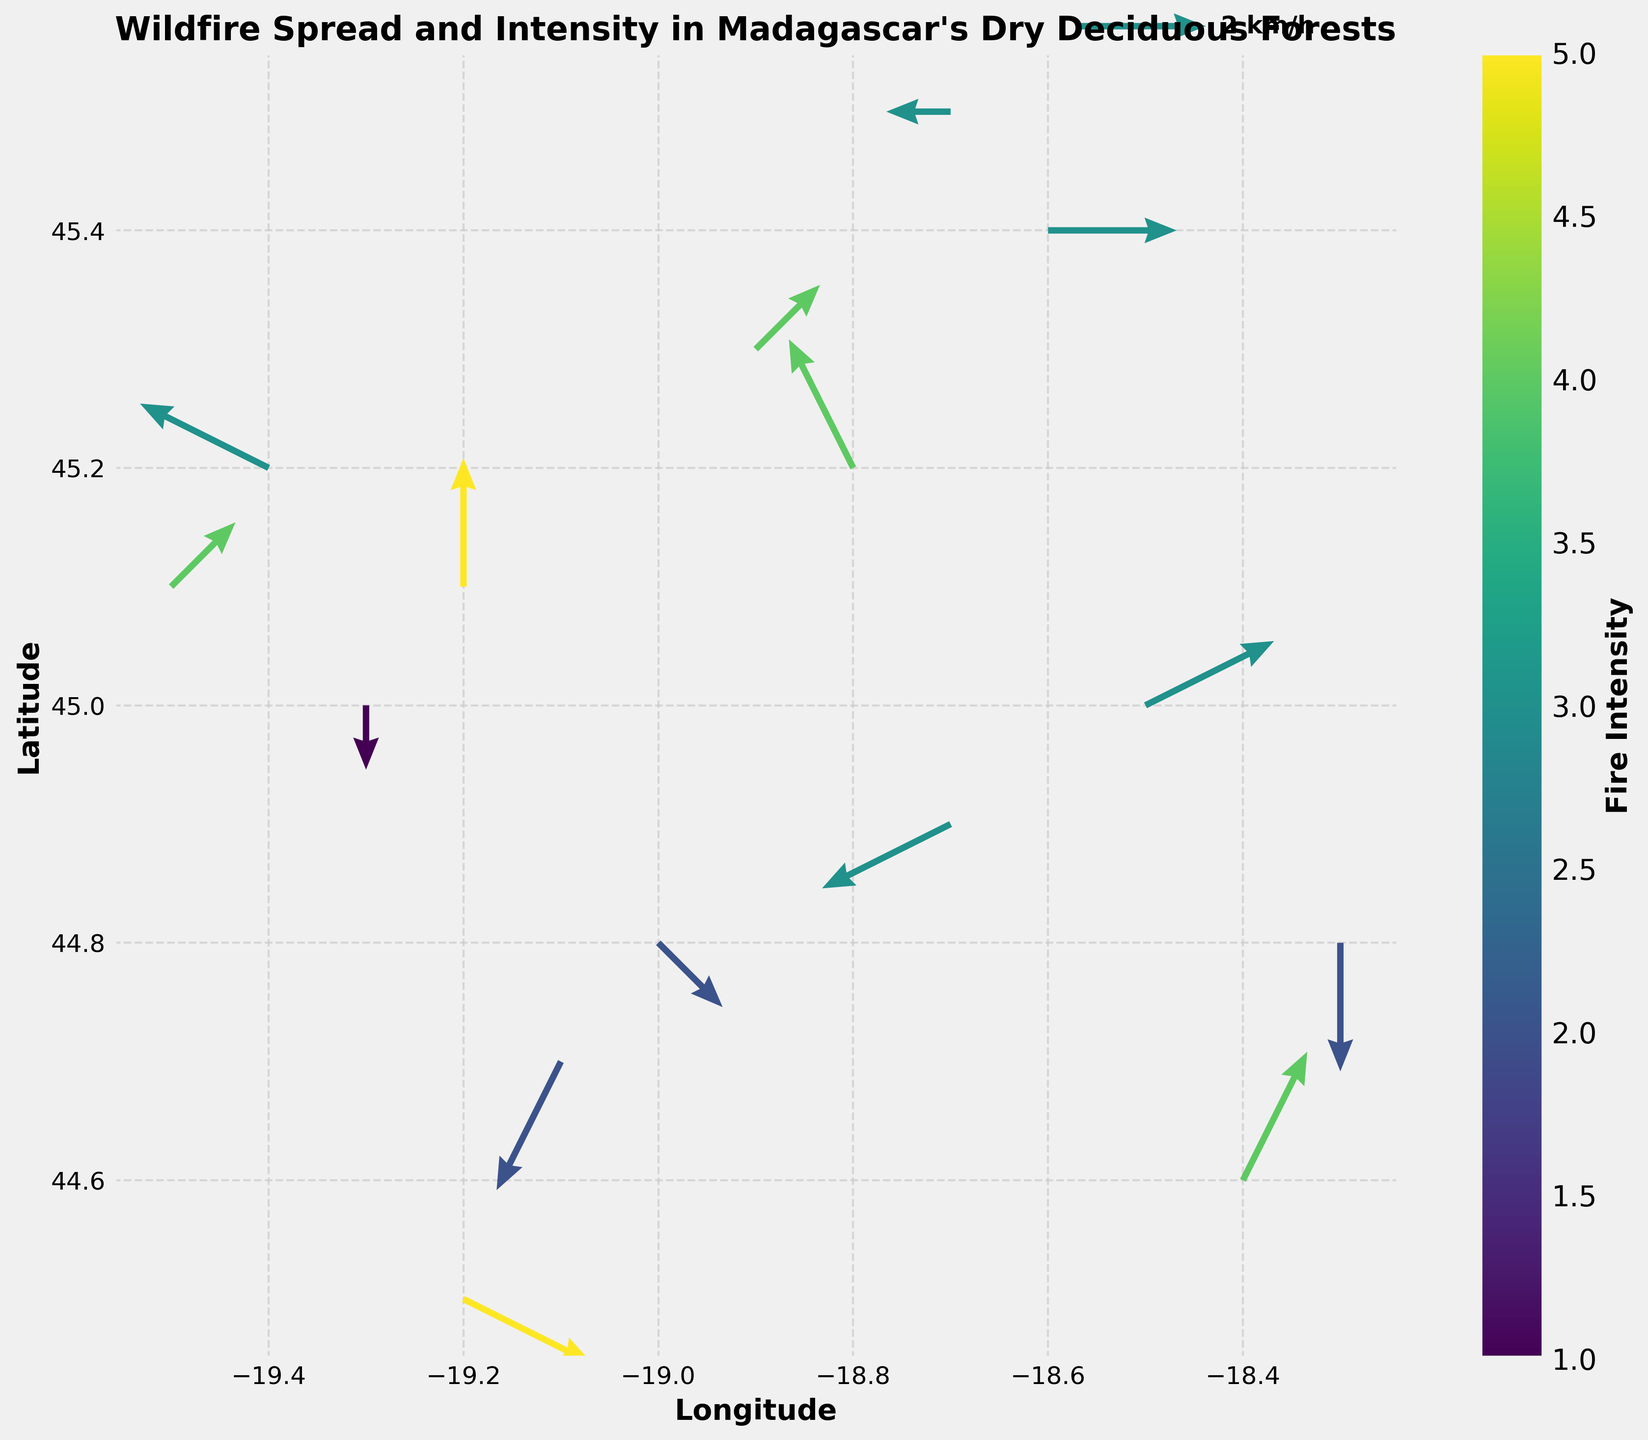what is the title of the figure? The title of the figure is displayed at the top of the plot. The plot's title is "Wildfire Spread and Intensity in Madagascar's Dry Deciduous Forests."
Answer: Wildfire Spread and Intensity in Madagascar's Dry Deciduous Forests how many data points are plotted in the figure? Each arrow in the quiver plot represents a data point. Count the arrows, which are 15 in total.
Answer: 15 what is the colorbar indicating? The colorbar represents the fire intensity, with its label "Fire Intensity" and a gradient of colors that likely ranges from low to high intensity.
Answer: Fire Intensity which direction does the fire spread at the data point (longitude=-18.5, latitude=45.0)? At (longitude=-18.5, latitude=45.0), the vector (2, 1) indicates that the fire spreads 2 units eastward and 1 unit northward.
Answer: East-North-East where is the location with the highest fire intensity, and what is the corresponding intensity value? Among the displayed data points, the highest intensity corresponds to the most intense color on the colorbar. The vector at (longitude=-19.2, latitude=45.1) has an intensity of 5.
Answer: (longitude=-19.2, latitude=45.1) with intensity 5 which data point shows a fire spreading southward? A vector pointing downward indicates a southward spread. The vector at (longitude=-19.1, latitude=44.7) with components (-1, -2) spreads southward.
Answer: (longitude=-19.1, latitude=44.7) how does the direction and magnitude of fire spread differ between the points with intensities 2 and 4? The point with intensity 2 at (longitude=-19.0, latitude=44.8) has a vector (1, -1), while the point with intensity 4 at (longitude=-18.8, latitude=45.2) has a vector (-1, 2). The former spreads southeastward with a smaller magnitude, and the latter spreads north-westward with a greater magnitude.
Answer: South-East with smaller magnitude vs. North-West with greater magnitude how many arrows represent a northward fire spread? Vectors with a positive v component indicate a northward direction. Counting such vectors in the data, there are 6 arrows.
Answer: 6 What is the average fire intensity among all the plotted data points? Sum the fire intensities and divide by the number of data points. The sum is 3 + 4 + 2 + 5 + 3 + 4 + 2 + 3 + 1 + 4 + 3 + 2 + 5 + 3 + 4 = 48, and there are 15 data points. So, the average intensity is 48/15 = 3.2.
Answer: 3.2 